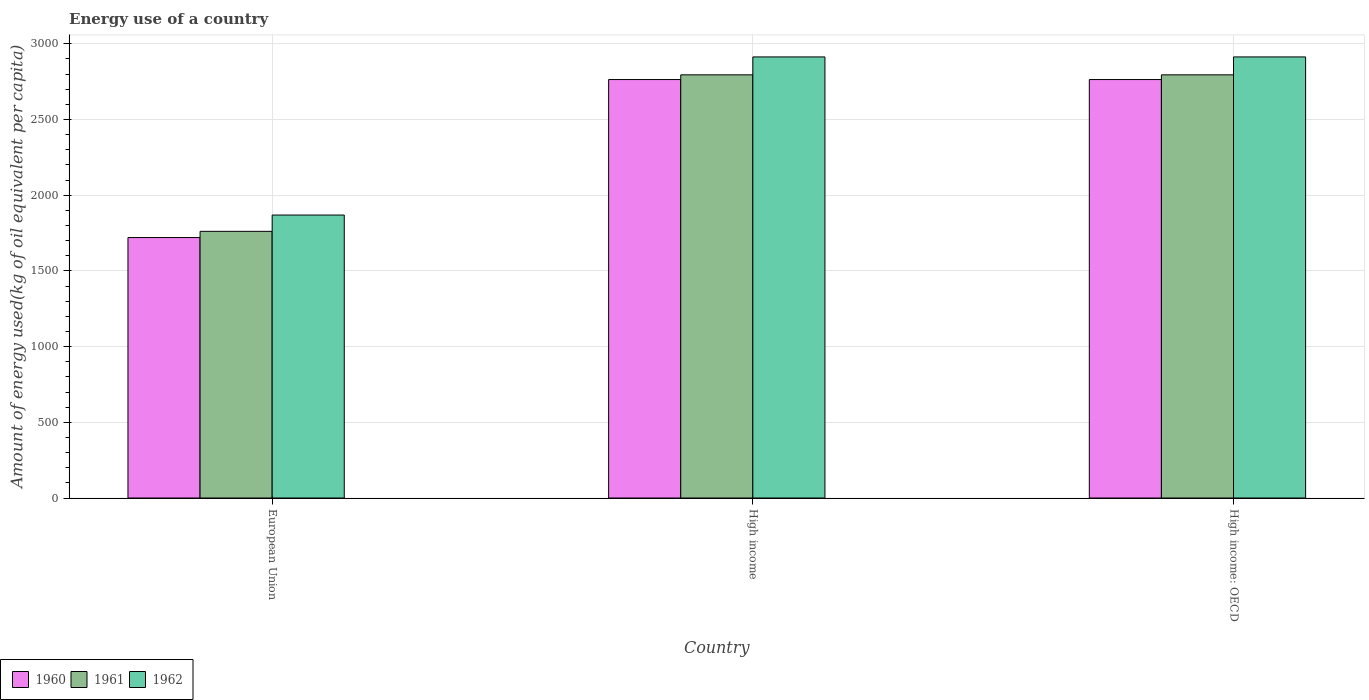How many different coloured bars are there?
Offer a very short reply. 3. Are the number of bars per tick equal to the number of legend labels?
Ensure brevity in your answer.  Yes. How many bars are there on the 2nd tick from the left?
Give a very brief answer. 3. What is the label of the 3rd group of bars from the left?
Keep it short and to the point. High income: OECD. In how many cases, is the number of bars for a given country not equal to the number of legend labels?
Provide a short and direct response. 0. What is the amount of energy used in in 1962 in European Union?
Make the answer very short. 1869.04. Across all countries, what is the maximum amount of energy used in in 1960?
Make the answer very short. 2763.96. Across all countries, what is the minimum amount of energy used in in 1960?
Provide a succinct answer. 1720.32. In which country was the amount of energy used in in 1961 minimum?
Give a very brief answer. European Union. What is the total amount of energy used in in 1960 in the graph?
Your answer should be very brief. 7248.24. What is the difference between the amount of energy used in in 1962 in High income and that in High income: OECD?
Offer a terse response. 0. What is the difference between the amount of energy used in in 1962 in High income: OECD and the amount of energy used in in 1961 in European Union?
Give a very brief answer. 1152.02. What is the average amount of energy used in in 1962 per country?
Your answer should be very brief. 2565.3. What is the difference between the amount of energy used in of/in 1962 and amount of energy used in of/in 1961 in High income?
Make the answer very short. 118.28. In how many countries, is the amount of energy used in in 1960 greater than 1800 kg?
Your answer should be very brief. 2. Is the amount of energy used in in 1961 in European Union less than that in High income: OECD?
Keep it short and to the point. Yes. Is the difference between the amount of energy used in in 1962 in European Union and High income: OECD greater than the difference between the amount of energy used in in 1961 in European Union and High income: OECD?
Provide a succinct answer. No. What is the difference between the highest and the second highest amount of energy used in in 1962?
Offer a very short reply. 1044.39. What is the difference between the highest and the lowest amount of energy used in in 1961?
Offer a very short reply. 1033.73. Is the sum of the amount of energy used in in 1960 in European Union and High income: OECD greater than the maximum amount of energy used in in 1962 across all countries?
Keep it short and to the point. Yes. How many bars are there?
Offer a very short reply. 9. Does the graph contain any zero values?
Make the answer very short. No. Does the graph contain grids?
Offer a terse response. Yes. How many legend labels are there?
Ensure brevity in your answer.  3. What is the title of the graph?
Ensure brevity in your answer.  Energy use of a country. What is the label or title of the Y-axis?
Provide a succinct answer. Amount of energy used(kg of oil equivalent per capita). What is the Amount of energy used(kg of oil equivalent per capita) in 1960 in European Union?
Keep it short and to the point. 1720.32. What is the Amount of energy used(kg of oil equivalent per capita) in 1961 in European Union?
Your answer should be very brief. 1761.41. What is the Amount of energy used(kg of oil equivalent per capita) in 1962 in European Union?
Ensure brevity in your answer.  1869.04. What is the Amount of energy used(kg of oil equivalent per capita) of 1960 in High income?
Your answer should be very brief. 2763.96. What is the Amount of energy used(kg of oil equivalent per capita) in 1961 in High income?
Provide a succinct answer. 2795.14. What is the Amount of energy used(kg of oil equivalent per capita) in 1962 in High income?
Offer a terse response. 2913.43. What is the Amount of energy used(kg of oil equivalent per capita) of 1960 in High income: OECD?
Offer a very short reply. 2763.96. What is the Amount of energy used(kg of oil equivalent per capita) in 1961 in High income: OECD?
Provide a short and direct response. 2795.14. What is the Amount of energy used(kg of oil equivalent per capita) of 1962 in High income: OECD?
Your answer should be compact. 2913.43. Across all countries, what is the maximum Amount of energy used(kg of oil equivalent per capita) of 1960?
Keep it short and to the point. 2763.96. Across all countries, what is the maximum Amount of energy used(kg of oil equivalent per capita) in 1961?
Your response must be concise. 2795.14. Across all countries, what is the maximum Amount of energy used(kg of oil equivalent per capita) in 1962?
Keep it short and to the point. 2913.43. Across all countries, what is the minimum Amount of energy used(kg of oil equivalent per capita) of 1960?
Offer a very short reply. 1720.32. Across all countries, what is the minimum Amount of energy used(kg of oil equivalent per capita) in 1961?
Keep it short and to the point. 1761.41. Across all countries, what is the minimum Amount of energy used(kg of oil equivalent per capita) of 1962?
Ensure brevity in your answer.  1869.04. What is the total Amount of energy used(kg of oil equivalent per capita) in 1960 in the graph?
Your answer should be compact. 7248.24. What is the total Amount of energy used(kg of oil equivalent per capita) of 1961 in the graph?
Offer a terse response. 7351.69. What is the total Amount of energy used(kg of oil equivalent per capita) of 1962 in the graph?
Ensure brevity in your answer.  7695.89. What is the difference between the Amount of energy used(kg of oil equivalent per capita) of 1960 in European Union and that in High income?
Your response must be concise. -1043.64. What is the difference between the Amount of energy used(kg of oil equivalent per capita) of 1961 in European Union and that in High income?
Make the answer very short. -1033.73. What is the difference between the Amount of energy used(kg of oil equivalent per capita) in 1962 in European Union and that in High income?
Offer a terse response. -1044.39. What is the difference between the Amount of energy used(kg of oil equivalent per capita) of 1960 in European Union and that in High income: OECD?
Make the answer very short. -1043.64. What is the difference between the Amount of energy used(kg of oil equivalent per capita) in 1961 in European Union and that in High income: OECD?
Offer a terse response. -1033.73. What is the difference between the Amount of energy used(kg of oil equivalent per capita) in 1962 in European Union and that in High income: OECD?
Provide a succinct answer. -1044.39. What is the difference between the Amount of energy used(kg of oil equivalent per capita) of 1960 in European Union and the Amount of energy used(kg of oil equivalent per capita) of 1961 in High income?
Offer a terse response. -1074.82. What is the difference between the Amount of energy used(kg of oil equivalent per capita) of 1960 in European Union and the Amount of energy used(kg of oil equivalent per capita) of 1962 in High income?
Offer a terse response. -1193.11. What is the difference between the Amount of energy used(kg of oil equivalent per capita) in 1961 in European Union and the Amount of energy used(kg of oil equivalent per capita) in 1962 in High income?
Offer a very short reply. -1152.02. What is the difference between the Amount of energy used(kg of oil equivalent per capita) in 1960 in European Union and the Amount of energy used(kg of oil equivalent per capita) in 1961 in High income: OECD?
Offer a terse response. -1074.82. What is the difference between the Amount of energy used(kg of oil equivalent per capita) in 1960 in European Union and the Amount of energy used(kg of oil equivalent per capita) in 1962 in High income: OECD?
Give a very brief answer. -1193.11. What is the difference between the Amount of energy used(kg of oil equivalent per capita) in 1961 in European Union and the Amount of energy used(kg of oil equivalent per capita) in 1962 in High income: OECD?
Make the answer very short. -1152.02. What is the difference between the Amount of energy used(kg of oil equivalent per capita) in 1960 in High income and the Amount of energy used(kg of oil equivalent per capita) in 1961 in High income: OECD?
Give a very brief answer. -31.18. What is the difference between the Amount of energy used(kg of oil equivalent per capita) of 1960 in High income and the Amount of energy used(kg of oil equivalent per capita) of 1962 in High income: OECD?
Make the answer very short. -149.47. What is the difference between the Amount of energy used(kg of oil equivalent per capita) in 1961 in High income and the Amount of energy used(kg of oil equivalent per capita) in 1962 in High income: OECD?
Provide a short and direct response. -118.28. What is the average Amount of energy used(kg of oil equivalent per capita) of 1960 per country?
Your answer should be compact. 2416.08. What is the average Amount of energy used(kg of oil equivalent per capita) of 1961 per country?
Offer a terse response. 2450.56. What is the average Amount of energy used(kg of oil equivalent per capita) in 1962 per country?
Your answer should be compact. 2565.3. What is the difference between the Amount of energy used(kg of oil equivalent per capita) of 1960 and Amount of energy used(kg of oil equivalent per capita) of 1961 in European Union?
Offer a very short reply. -41.09. What is the difference between the Amount of energy used(kg of oil equivalent per capita) of 1960 and Amount of energy used(kg of oil equivalent per capita) of 1962 in European Union?
Your response must be concise. -148.72. What is the difference between the Amount of energy used(kg of oil equivalent per capita) in 1961 and Amount of energy used(kg of oil equivalent per capita) in 1962 in European Union?
Offer a terse response. -107.63. What is the difference between the Amount of energy used(kg of oil equivalent per capita) of 1960 and Amount of energy used(kg of oil equivalent per capita) of 1961 in High income?
Provide a short and direct response. -31.18. What is the difference between the Amount of energy used(kg of oil equivalent per capita) of 1960 and Amount of energy used(kg of oil equivalent per capita) of 1962 in High income?
Give a very brief answer. -149.47. What is the difference between the Amount of energy used(kg of oil equivalent per capita) of 1961 and Amount of energy used(kg of oil equivalent per capita) of 1962 in High income?
Make the answer very short. -118.28. What is the difference between the Amount of energy used(kg of oil equivalent per capita) of 1960 and Amount of energy used(kg of oil equivalent per capita) of 1961 in High income: OECD?
Keep it short and to the point. -31.18. What is the difference between the Amount of energy used(kg of oil equivalent per capita) in 1960 and Amount of energy used(kg of oil equivalent per capita) in 1962 in High income: OECD?
Provide a succinct answer. -149.47. What is the difference between the Amount of energy used(kg of oil equivalent per capita) in 1961 and Amount of energy used(kg of oil equivalent per capita) in 1962 in High income: OECD?
Keep it short and to the point. -118.28. What is the ratio of the Amount of energy used(kg of oil equivalent per capita) of 1960 in European Union to that in High income?
Provide a succinct answer. 0.62. What is the ratio of the Amount of energy used(kg of oil equivalent per capita) in 1961 in European Union to that in High income?
Offer a very short reply. 0.63. What is the ratio of the Amount of energy used(kg of oil equivalent per capita) of 1962 in European Union to that in High income?
Your answer should be compact. 0.64. What is the ratio of the Amount of energy used(kg of oil equivalent per capita) in 1960 in European Union to that in High income: OECD?
Provide a short and direct response. 0.62. What is the ratio of the Amount of energy used(kg of oil equivalent per capita) of 1961 in European Union to that in High income: OECD?
Keep it short and to the point. 0.63. What is the ratio of the Amount of energy used(kg of oil equivalent per capita) in 1962 in European Union to that in High income: OECD?
Give a very brief answer. 0.64. What is the difference between the highest and the second highest Amount of energy used(kg of oil equivalent per capita) of 1962?
Your answer should be compact. 0. What is the difference between the highest and the lowest Amount of energy used(kg of oil equivalent per capita) in 1960?
Your answer should be compact. 1043.64. What is the difference between the highest and the lowest Amount of energy used(kg of oil equivalent per capita) of 1961?
Provide a short and direct response. 1033.73. What is the difference between the highest and the lowest Amount of energy used(kg of oil equivalent per capita) in 1962?
Offer a terse response. 1044.39. 